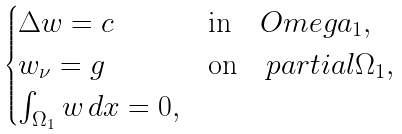<formula> <loc_0><loc_0><loc_500><loc_500>\begin{cases} \Delta w = c \quad & \text {in} \quad O m e g a _ { 1 } , \\ w _ { \nu } = g \quad & \text {on} \quad p a r t i a l \Omega _ { 1 } , \\ \int _ { \Omega _ { 1 } } w \, d x = 0 , \end{cases}</formula> 